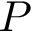Convert formula to latex. <formula><loc_0><loc_0><loc_500><loc_500>P</formula> 